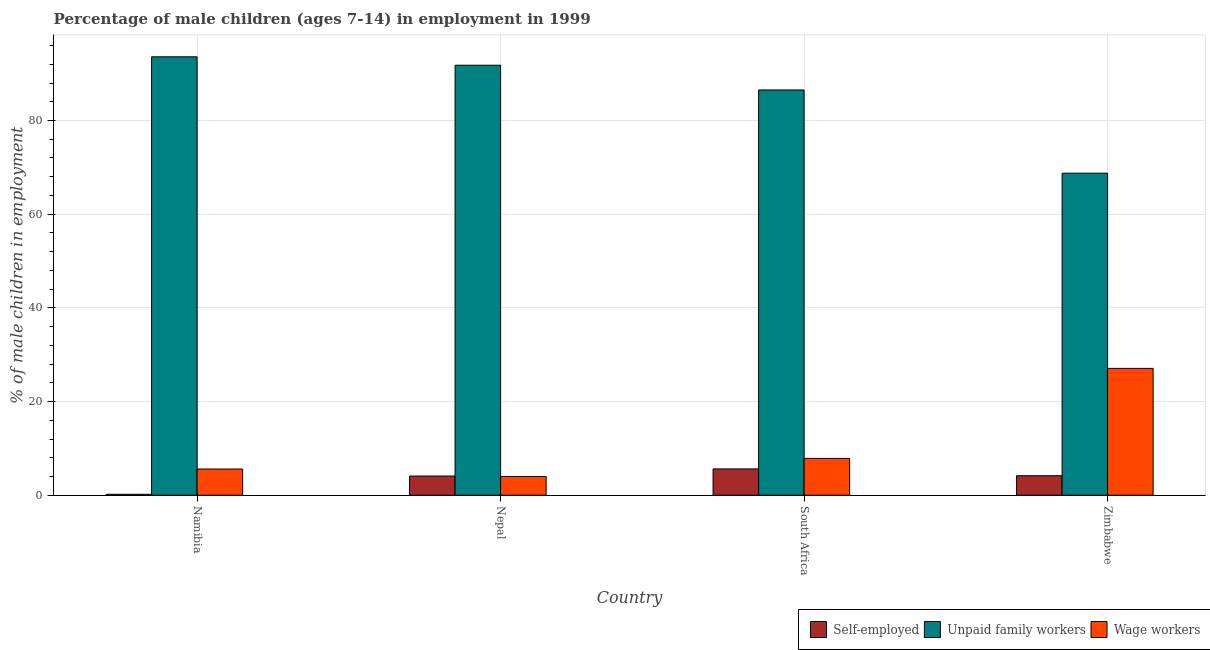How many groups of bars are there?
Your answer should be very brief. 4. Are the number of bars on each tick of the X-axis equal?
Your answer should be compact. Yes. What is the label of the 1st group of bars from the left?
Offer a very short reply. Namibia. In how many cases, is the number of bars for a given country not equal to the number of legend labels?
Offer a terse response. 0. What is the percentage of children employed as wage workers in Nepal?
Give a very brief answer. 4. Across all countries, what is the maximum percentage of self employed children?
Provide a succinct answer. 5.62. In which country was the percentage of self employed children maximum?
Keep it short and to the point. South Africa. In which country was the percentage of children employed as wage workers minimum?
Make the answer very short. Nepal. What is the total percentage of children employed as wage workers in the graph?
Offer a terse response. 44.54. What is the difference between the percentage of self employed children in Namibia and that in Zimbabwe?
Offer a very short reply. -3.97. What is the difference between the percentage of children employed as unpaid family workers in South Africa and the percentage of self employed children in Nepal?
Give a very brief answer. 82.42. What is the average percentage of self employed children per country?
Offer a very short reply. 3.52. What is the difference between the percentage of self employed children and percentage of children employed as unpaid family workers in Nepal?
Your answer should be compact. -87.7. In how many countries, is the percentage of children employed as unpaid family workers greater than 16 %?
Your answer should be compact. 4. What is the ratio of the percentage of self employed children in Namibia to that in Nepal?
Your answer should be very brief. 0.05. Is the percentage of children employed as wage workers in Nepal less than that in South Africa?
Provide a short and direct response. Yes. Is the difference between the percentage of self employed children in Nepal and South Africa greater than the difference between the percentage of children employed as wage workers in Nepal and South Africa?
Provide a short and direct response. Yes. What is the difference between the highest and the second highest percentage of children employed as wage workers?
Your response must be concise. 19.22. What is the difference between the highest and the lowest percentage of self employed children?
Your answer should be very brief. 5.42. In how many countries, is the percentage of children employed as wage workers greater than the average percentage of children employed as wage workers taken over all countries?
Offer a terse response. 1. What does the 1st bar from the left in South Africa represents?
Your answer should be very brief. Self-employed. What does the 1st bar from the right in South Africa represents?
Make the answer very short. Wage workers. How many bars are there?
Provide a succinct answer. 12. Are all the bars in the graph horizontal?
Keep it short and to the point. No. How many countries are there in the graph?
Your answer should be compact. 4. Does the graph contain any zero values?
Keep it short and to the point. No. How are the legend labels stacked?
Give a very brief answer. Horizontal. What is the title of the graph?
Keep it short and to the point. Percentage of male children (ages 7-14) in employment in 1999. What is the label or title of the Y-axis?
Ensure brevity in your answer.  % of male children in employment. What is the % of male children in employment in Self-employed in Namibia?
Make the answer very short. 0.2. What is the % of male children in employment in Unpaid family workers in Namibia?
Make the answer very short. 93.6. What is the % of male children in employment in Wage workers in Namibia?
Provide a succinct answer. 5.6. What is the % of male children in employment in Unpaid family workers in Nepal?
Provide a succinct answer. 91.8. What is the % of male children in employment of Self-employed in South Africa?
Your response must be concise. 5.62. What is the % of male children in employment in Unpaid family workers in South Africa?
Offer a terse response. 86.52. What is the % of male children in employment of Wage workers in South Africa?
Make the answer very short. 7.86. What is the % of male children in employment of Self-employed in Zimbabwe?
Provide a short and direct response. 4.17. What is the % of male children in employment of Unpaid family workers in Zimbabwe?
Provide a short and direct response. 68.75. What is the % of male children in employment of Wage workers in Zimbabwe?
Your answer should be compact. 27.08. Across all countries, what is the maximum % of male children in employment in Self-employed?
Your response must be concise. 5.62. Across all countries, what is the maximum % of male children in employment of Unpaid family workers?
Keep it short and to the point. 93.6. Across all countries, what is the maximum % of male children in employment in Wage workers?
Give a very brief answer. 27.08. Across all countries, what is the minimum % of male children in employment of Unpaid family workers?
Make the answer very short. 68.75. Across all countries, what is the minimum % of male children in employment in Wage workers?
Give a very brief answer. 4. What is the total % of male children in employment in Self-employed in the graph?
Provide a short and direct response. 14.09. What is the total % of male children in employment in Unpaid family workers in the graph?
Give a very brief answer. 340.67. What is the total % of male children in employment in Wage workers in the graph?
Keep it short and to the point. 44.54. What is the difference between the % of male children in employment in Self-employed in Namibia and that in Nepal?
Your response must be concise. -3.9. What is the difference between the % of male children in employment of Unpaid family workers in Namibia and that in Nepal?
Give a very brief answer. 1.8. What is the difference between the % of male children in employment of Self-employed in Namibia and that in South Africa?
Make the answer very short. -5.42. What is the difference between the % of male children in employment in Unpaid family workers in Namibia and that in South Africa?
Provide a short and direct response. 7.08. What is the difference between the % of male children in employment of Wage workers in Namibia and that in South Africa?
Your response must be concise. -2.26. What is the difference between the % of male children in employment in Self-employed in Namibia and that in Zimbabwe?
Offer a very short reply. -3.97. What is the difference between the % of male children in employment of Unpaid family workers in Namibia and that in Zimbabwe?
Offer a terse response. 24.85. What is the difference between the % of male children in employment of Wage workers in Namibia and that in Zimbabwe?
Offer a very short reply. -21.48. What is the difference between the % of male children in employment in Self-employed in Nepal and that in South Africa?
Your answer should be very brief. -1.52. What is the difference between the % of male children in employment in Unpaid family workers in Nepal and that in South Africa?
Your response must be concise. 5.28. What is the difference between the % of male children in employment in Wage workers in Nepal and that in South Africa?
Your response must be concise. -3.86. What is the difference between the % of male children in employment in Self-employed in Nepal and that in Zimbabwe?
Your response must be concise. -0.07. What is the difference between the % of male children in employment of Unpaid family workers in Nepal and that in Zimbabwe?
Provide a short and direct response. 23.05. What is the difference between the % of male children in employment in Wage workers in Nepal and that in Zimbabwe?
Offer a terse response. -23.08. What is the difference between the % of male children in employment of Self-employed in South Africa and that in Zimbabwe?
Your answer should be very brief. 1.45. What is the difference between the % of male children in employment of Unpaid family workers in South Africa and that in Zimbabwe?
Provide a succinct answer. 17.77. What is the difference between the % of male children in employment of Wage workers in South Africa and that in Zimbabwe?
Give a very brief answer. -19.22. What is the difference between the % of male children in employment in Self-employed in Namibia and the % of male children in employment in Unpaid family workers in Nepal?
Offer a very short reply. -91.6. What is the difference between the % of male children in employment in Unpaid family workers in Namibia and the % of male children in employment in Wage workers in Nepal?
Keep it short and to the point. 89.6. What is the difference between the % of male children in employment in Self-employed in Namibia and the % of male children in employment in Unpaid family workers in South Africa?
Your response must be concise. -86.32. What is the difference between the % of male children in employment in Self-employed in Namibia and the % of male children in employment in Wage workers in South Africa?
Your answer should be compact. -7.66. What is the difference between the % of male children in employment in Unpaid family workers in Namibia and the % of male children in employment in Wage workers in South Africa?
Offer a terse response. 85.74. What is the difference between the % of male children in employment of Self-employed in Namibia and the % of male children in employment of Unpaid family workers in Zimbabwe?
Keep it short and to the point. -68.55. What is the difference between the % of male children in employment of Self-employed in Namibia and the % of male children in employment of Wage workers in Zimbabwe?
Your answer should be compact. -26.88. What is the difference between the % of male children in employment of Unpaid family workers in Namibia and the % of male children in employment of Wage workers in Zimbabwe?
Ensure brevity in your answer.  66.52. What is the difference between the % of male children in employment in Self-employed in Nepal and the % of male children in employment in Unpaid family workers in South Africa?
Your answer should be very brief. -82.42. What is the difference between the % of male children in employment of Self-employed in Nepal and the % of male children in employment of Wage workers in South Africa?
Ensure brevity in your answer.  -3.76. What is the difference between the % of male children in employment in Unpaid family workers in Nepal and the % of male children in employment in Wage workers in South Africa?
Your answer should be compact. 83.94. What is the difference between the % of male children in employment in Self-employed in Nepal and the % of male children in employment in Unpaid family workers in Zimbabwe?
Offer a terse response. -64.65. What is the difference between the % of male children in employment of Self-employed in Nepal and the % of male children in employment of Wage workers in Zimbabwe?
Provide a short and direct response. -22.98. What is the difference between the % of male children in employment of Unpaid family workers in Nepal and the % of male children in employment of Wage workers in Zimbabwe?
Provide a short and direct response. 64.72. What is the difference between the % of male children in employment of Self-employed in South Africa and the % of male children in employment of Unpaid family workers in Zimbabwe?
Provide a succinct answer. -63.13. What is the difference between the % of male children in employment of Self-employed in South Africa and the % of male children in employment of Wage workers in Zimbabwe?
Ensure brevity in your answer.  -21.46. What is the difference between the % of male children in employment in Unpaid family workers in South Africa and the % of male children in employment in Wage workers in Zimbabwe?
Offer a very short reply. 59.44. What is the average % of male children in employment of Self-employed per country?
Provide a succinct answer. 3.52. What is the average % of male children in employment of Unpaid family workers per country?
Provide a succinct answer. 85.17. What is the average % of male children in employment of Wage workers per country?
Keep it short and to the point. 11.13. What is the difference between the % of male children in employment in Self-employed and % of male children in employment in Unpaid family workers in Namibia?
Give a very brief answer. -93.4. What is the difference between the % of male children in employment of Self-employed and % of male children in employment of Unpaid family workers in Nepal?
Provide a succinct answer. -87.7. What is the difference between the % of male children in employment in Unpaid family workers and % of male children in employment in Wage workers in Nepal?
Your answer should be very brief. 87.8. What is the difference between the % of male children in employment in Self-employed and % of male children in employment in Unpaid family workers in South Africa?
Your answer should be very brief. -80.9. What is the difference between the % of male children in employment of Self-employed and % of male children in employment of Wage workers in South Africa?
Your response must be concise. -2.24. What is the difference between the % of male children in employment in Unpaid family workers and % of male children in employment in Wage workers in South Africa?
Ensure brevity in your answer.  78.66. What is the difference between the % of male children in employment in Self-employed and % of male children in employment in Unpaid family workers in Zimbabwe?
Provide a short and direct response. -64.58. What is the difference between the % of male children in employment in Self-employed and % of male children in employment in Wage workers in Zimbabwe?
Provide a succinct answer. -22.91. What is the difference between the % of male children in employment in Unpaid family workers and % of male children in employment in Wage workers in Zimbabwe?
Your answer should be compact. 41.67. What is the ratio of the % of male children in employment in Self-employed in Namibia to that in Nepal?
Your response must be concise. 0.05. What is the ratio of the % of male children in employment of Unpaid family workers in Namibia to that in Nepal?
Give a very brief answer. 1.02. What is the ratio of the % of male children in employment of Wage workers in Namibia to that in Nepal?
Your answer should be compact. 1.4. What is the ratio of the % of male children in employment in Self-employed in Namibia to that in South Africa?
Give a very brief answer. 0.04. What is the ratio of the % of male children in employment in Unpaid family workers in Namibia to that in South Africa?
Ensure brevity in your answer.  1.08. What is the ratio of the % of male children in employment in Wage workers in Namibia to that in South Africa?
Provide a short and direct response. 0.71. What is the ratio of the % of male children in employment of Self-employed in Namibia to that in Zimbabwe?
Ensure brevity in your answer.  0.05. What is the ratio of the % of male children in employment in Unpaid family workers in Namibia to that in Zimbabwe?
Provide a short and direct response. 1.36. What is the ratio of the % of male children in employment of Wage workers in Namibia to that in Zimbabwe?
Offer a very short reply. 0.21. What is the ratio of the % of male children in employment of Self-employed in Nepal to that in South Africa?
Provide a short and direct response. 0.73. What is the ratio of the % of male children in employment of Unpaid family workers in Nepal to that in South Africa?
Your answer should be compact. 1.06. What is the ratio of the % of male children in employment of Wage workers in Nepal to that in South Africa?
Ensure brevity in your answer.  0.51. What is the ratio of the % of male children in employment in Self-employed in Nepal to that in Zimbabwe?
Keep it short and to the point. 0.98. What is the ratio of the % of male children in employment in Unpaid family workers in Nepal to that in Zimbabwe?
Your answer should be very brief. 1.34. What is the ratio of the % of male children in employment in Wage workers in Nepal to that in Zimbabwe?
Your response must be concise. 0.15. What is the ratio of the % of male children in employment of Self-employed in South Africa to that in Zimbabwe?
Provide a succinct answer. 1.35. What is the ratio of the % of male children in employment of Unpaid family workers in South Africa to that in Zimbabwe?
Provide a succinct answer. 1.26. What is the ratio of the % of male children in employment of Wage workers in South Africa to that in Zimbabwe?
Your answer should be very brief. 0.29. What is the difference between the highest and the second highest % of male children in employment in Self-employed?
Your answer should be compact. 1.45. What is the difference between the highest and the second highest % of male children in employment of Unpaid family workers?
Keep it short and to the point. 1.8. What is the difference between the highest and the second highest % of male children in employment of Wage workers?
Make the answer very short. 19.22. What is the difference between the highest and the lowest % of male children in employment in Self-employed?
Provide a succinct answer. 5.42. What is the difference between the highest and the lowest % of male children in employment of Unpaid family workers?
Your answer should be very brief. 24.85. What is the difference between the highest and the lowest % of male children in employment in Wage workers?
Your answer should be very brief. 23.08. 